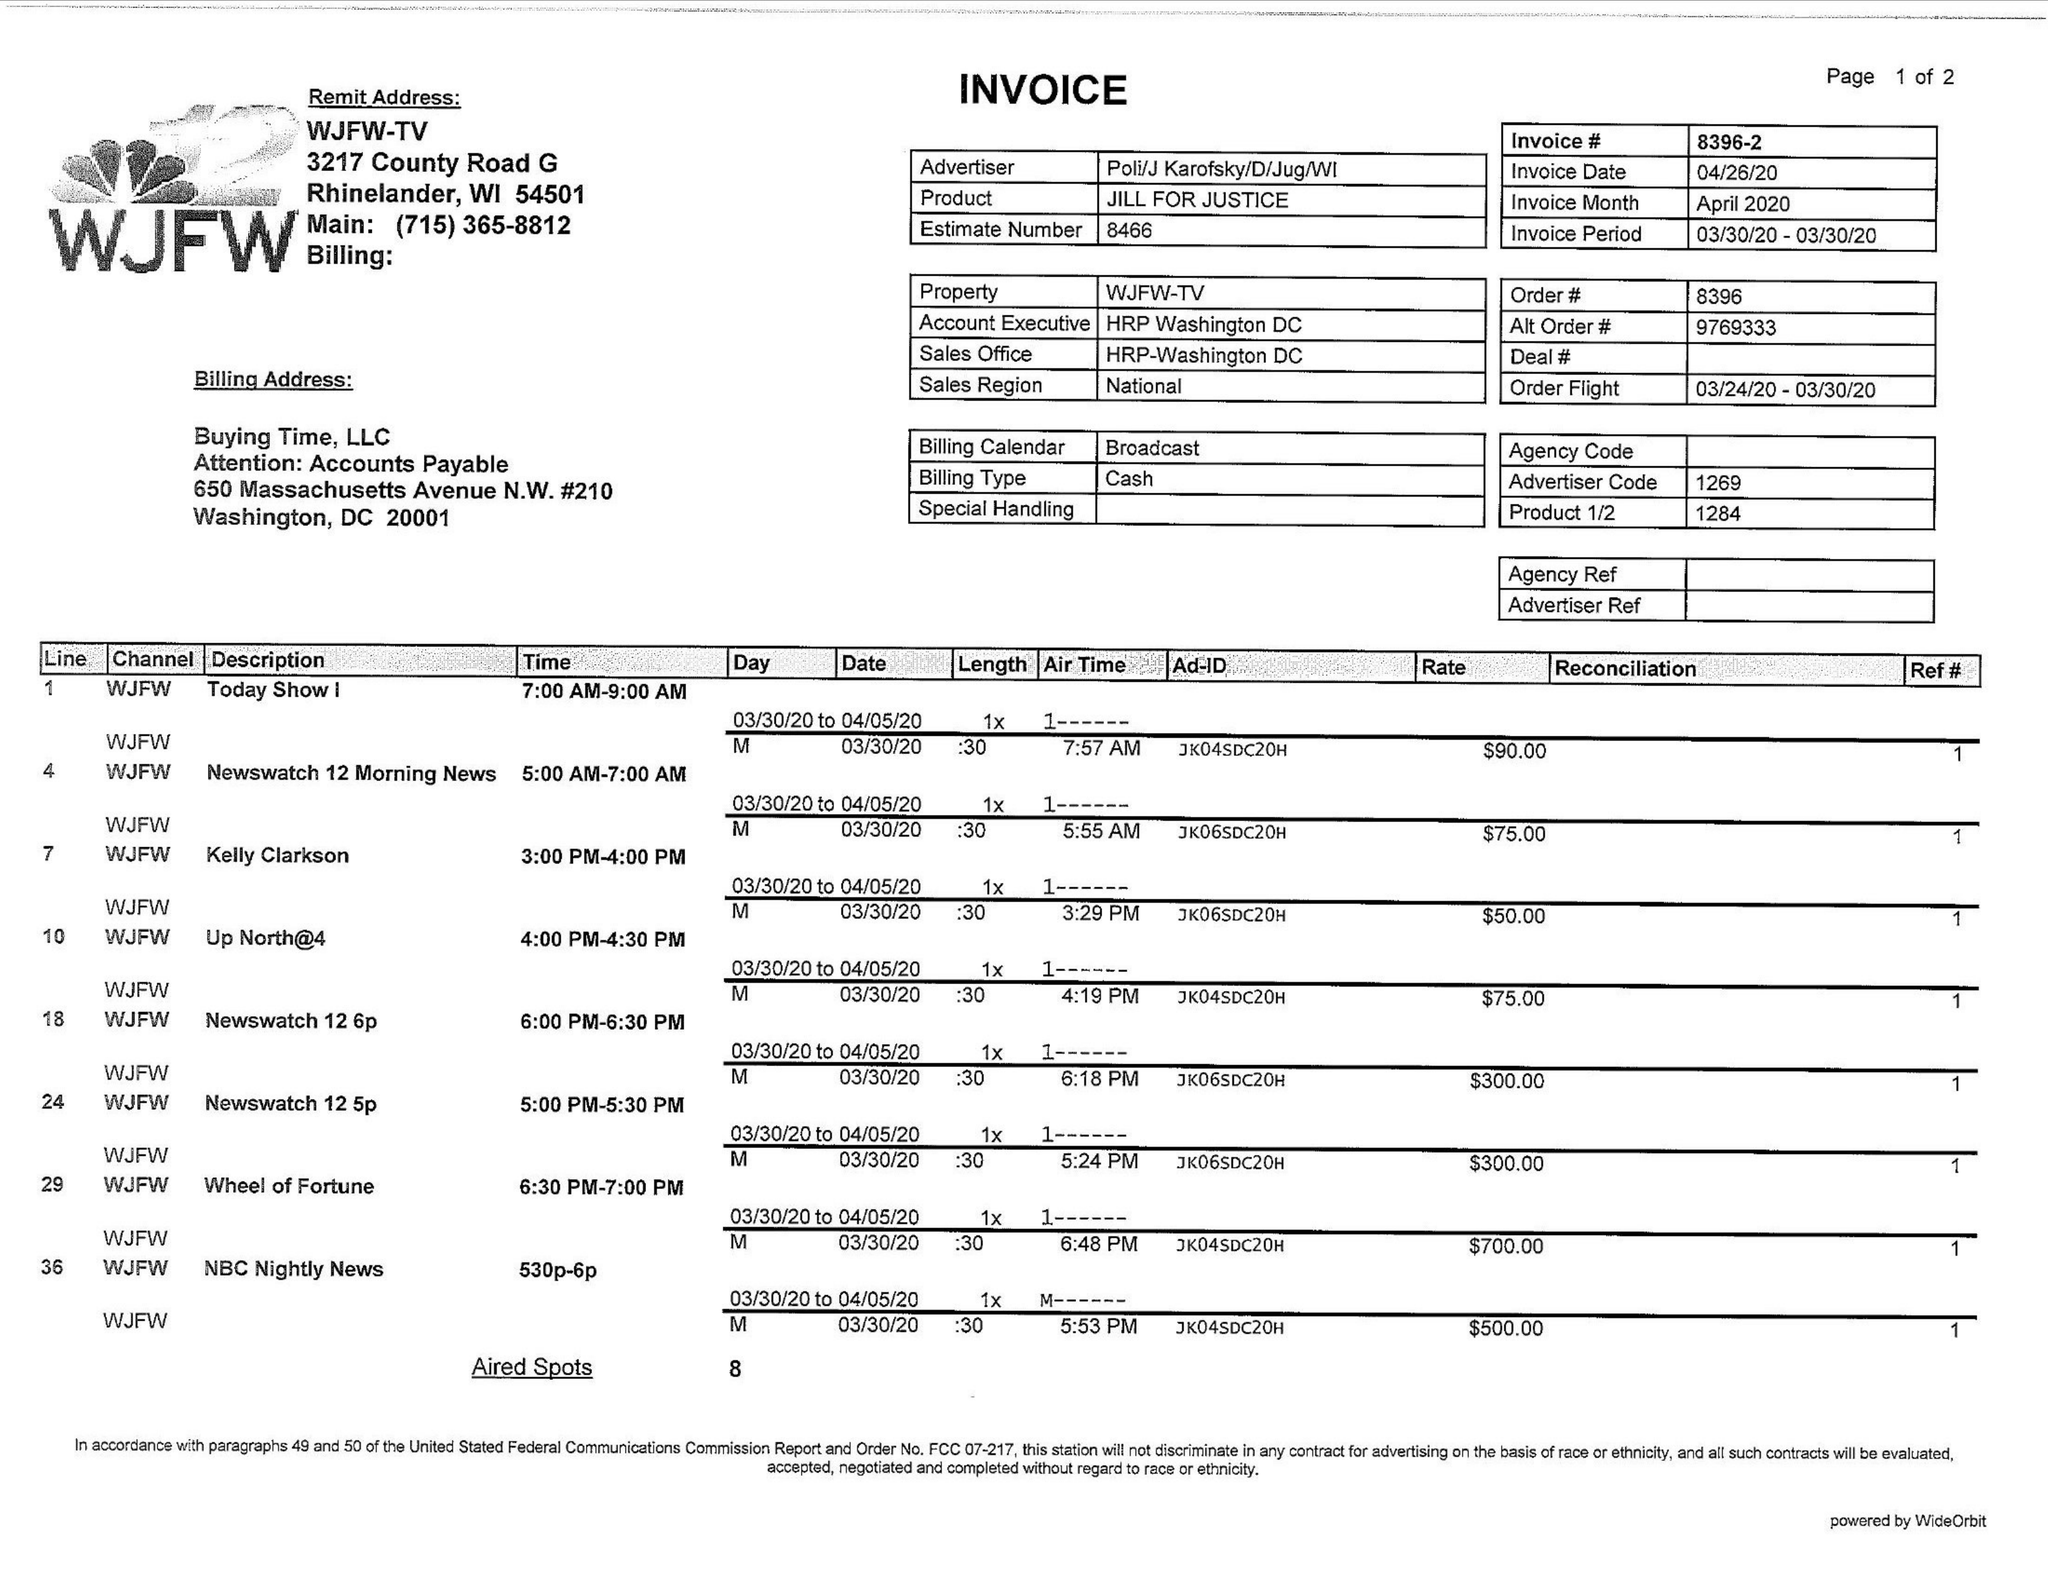What is the value for the flight_to?
Answer the question using a single word or phrase. 03/30/20 